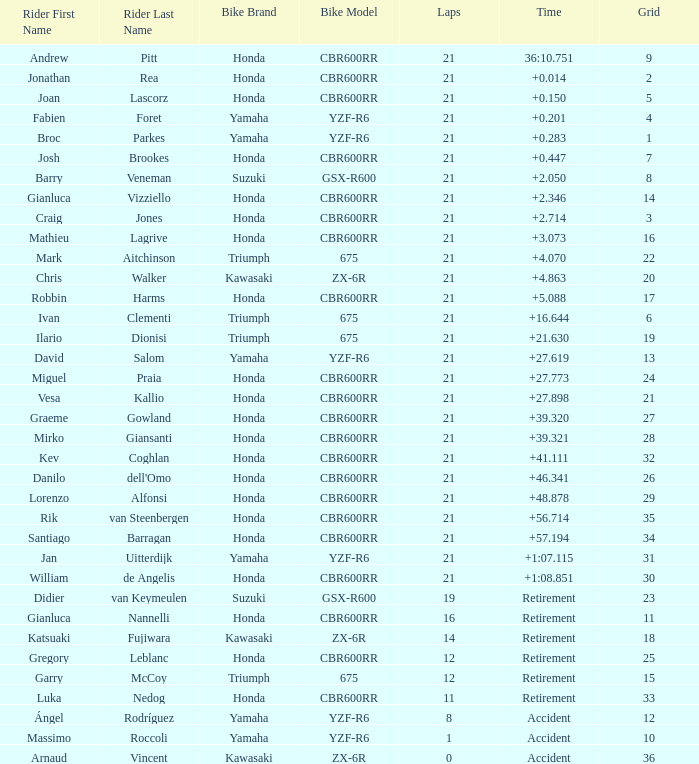Help me parse the entirety of this table. {'header': ['Rider First Name', 'Rider Last Name', 'Bike Brand', 'Bike Model', 'Laps', 'Time', 'Grid'], 'rows': [['Andrew', 'Pitt', 'Honda', 'CBR600RR', '21', '36:10.751', '9'], ['Jonathan', 'Rea', 'Honda', 'CBR600RR', '21', '+0.014', '2'], ['Joan', 'Lascorz', 'Honda', 'CBR600RR', '21', '+0.150', '5'], ['Fabien', 'Foret', 'Yamaha', 'YZF-R6', '21', '+0.201', '4'], ['Broc', 'Parkes', 'Yamaha', 'YZF-R6', '21', '+0.283', '1'], ['Josh', 'Brookes', 'Honda', 'CBR600RR', '21', '+0.447', '7'], ['Barry', 'Veneman', 'Suzuki', 'GSX-R600', '21', '+2.050', '8'], ['Gianluca', 'Vizziello', 'Honda', 'CBR600RR', '21', '+2.346', '14'], ['Craig', 'Jones', 'Honda', 'CBR600RR', '21', '+2.714', '3'], ['Mathieu', 'Lagrive', 'Honda', 'CBR600RR', '21', '+3.073', '16'], ['Mark', 'Aitchinson', 'Triumph', '675', '21', '+4.070', '22'], ['Chris', 'Walker', 'Kawasaki', 'ZX-6R', '21', '+4.863', '20'], ['Robbin', 'Harms', 'Honda', 'CBR600RR', '21', '+5.088', '17'], ['Ivan', 'Clementi', 'Triumph', '675', '21', '+16.644', '6'], ['Ilario', 'Dionisi', 'Triumph', '675', '21', '+21.630', '19'], ['David', 'Salom', 'Yamaha', 'YZF-R6', '21', '+27.619', '13'], ['Miguel', 'Praia', 'Honda', 'CBR600RR', '21', '+27.773', '24'], ['Vesa', 'Kallio', 'Honda', 'CBR600RR', '21', '+27.898', '21'], ['Graeme', 'Gowland', 'Honda', 'CBR600RR', '21', '+39.320', '27'], ['Mirko', 'Giansanti', 'Honda', 'CBR600RR', '21', '+39.321', '28'], ['Kev', 'Coghlan', 'Honda', 'CBR600RR', '21', '+41.111', '32'], ['Danilo', "dell'Omo", 'Honda', 'CBR600RR', '21', '+46.341', '26'], ['Lorenzo', 'Alfonsi', 'Honda', 'CBR600RR', '21', '+48.878', '29'], ['Rik', 'van Steenbergen', 'Honda', 'CBR600RR', '21', '+56.714', '35'], ['Santiago', 'Barragan', 'Honda', 'CBR600RR', '21', '+57.194', '34'], ['Jan', 'Uitterdijk', 'Yamaha', 'YZF-R6', '21', '+1:07.115', '31'], ['William', 'de Angelis', 'Honda', 'CBR600RR', '21', '+1:08.851', '30'], ['Didier', 'van Keymeulen', 'Suzuki', 'GSX-R600', '19', 'Retirement', '23'], ['Gianluca', 'Nannelli', 'Honda', 'CBR600RR', '16', 'Retirement', '11'], ['Katsuaki', 'Fujiwara', 'Kawasaki', 'ZX-6R', '14', 'Retirement', '18'], ['Gregory', 'Leblanc', 'Honda', 'CBR600RR', '12', 'Retirement', '25'], ['Garry', 'McCoy', 'Triumph', '675', '12', 'Retirement', '15'], ['Luka', 'Nedog', 'Honda', 'CBR600RR', '11', 'Retirement', '33'], ['Ángel', 'Rodríguez', 'Yamaha', 'YZF-R6', '8', 'Accident', '12'], ['Massimo', 'Roccoli', 'Yamaha', 'YZF-R6', '1', 'Accident', '10'], ['Arnaud', 'Vincent', 'Kawasaki', 'ZX-6R', '0', 'Accident', '36']]} What is the driver with the laps under 16, grid of 10, a bike of Yamaha YZF-R6, and ended with an accident? Massimo Roccoli. 